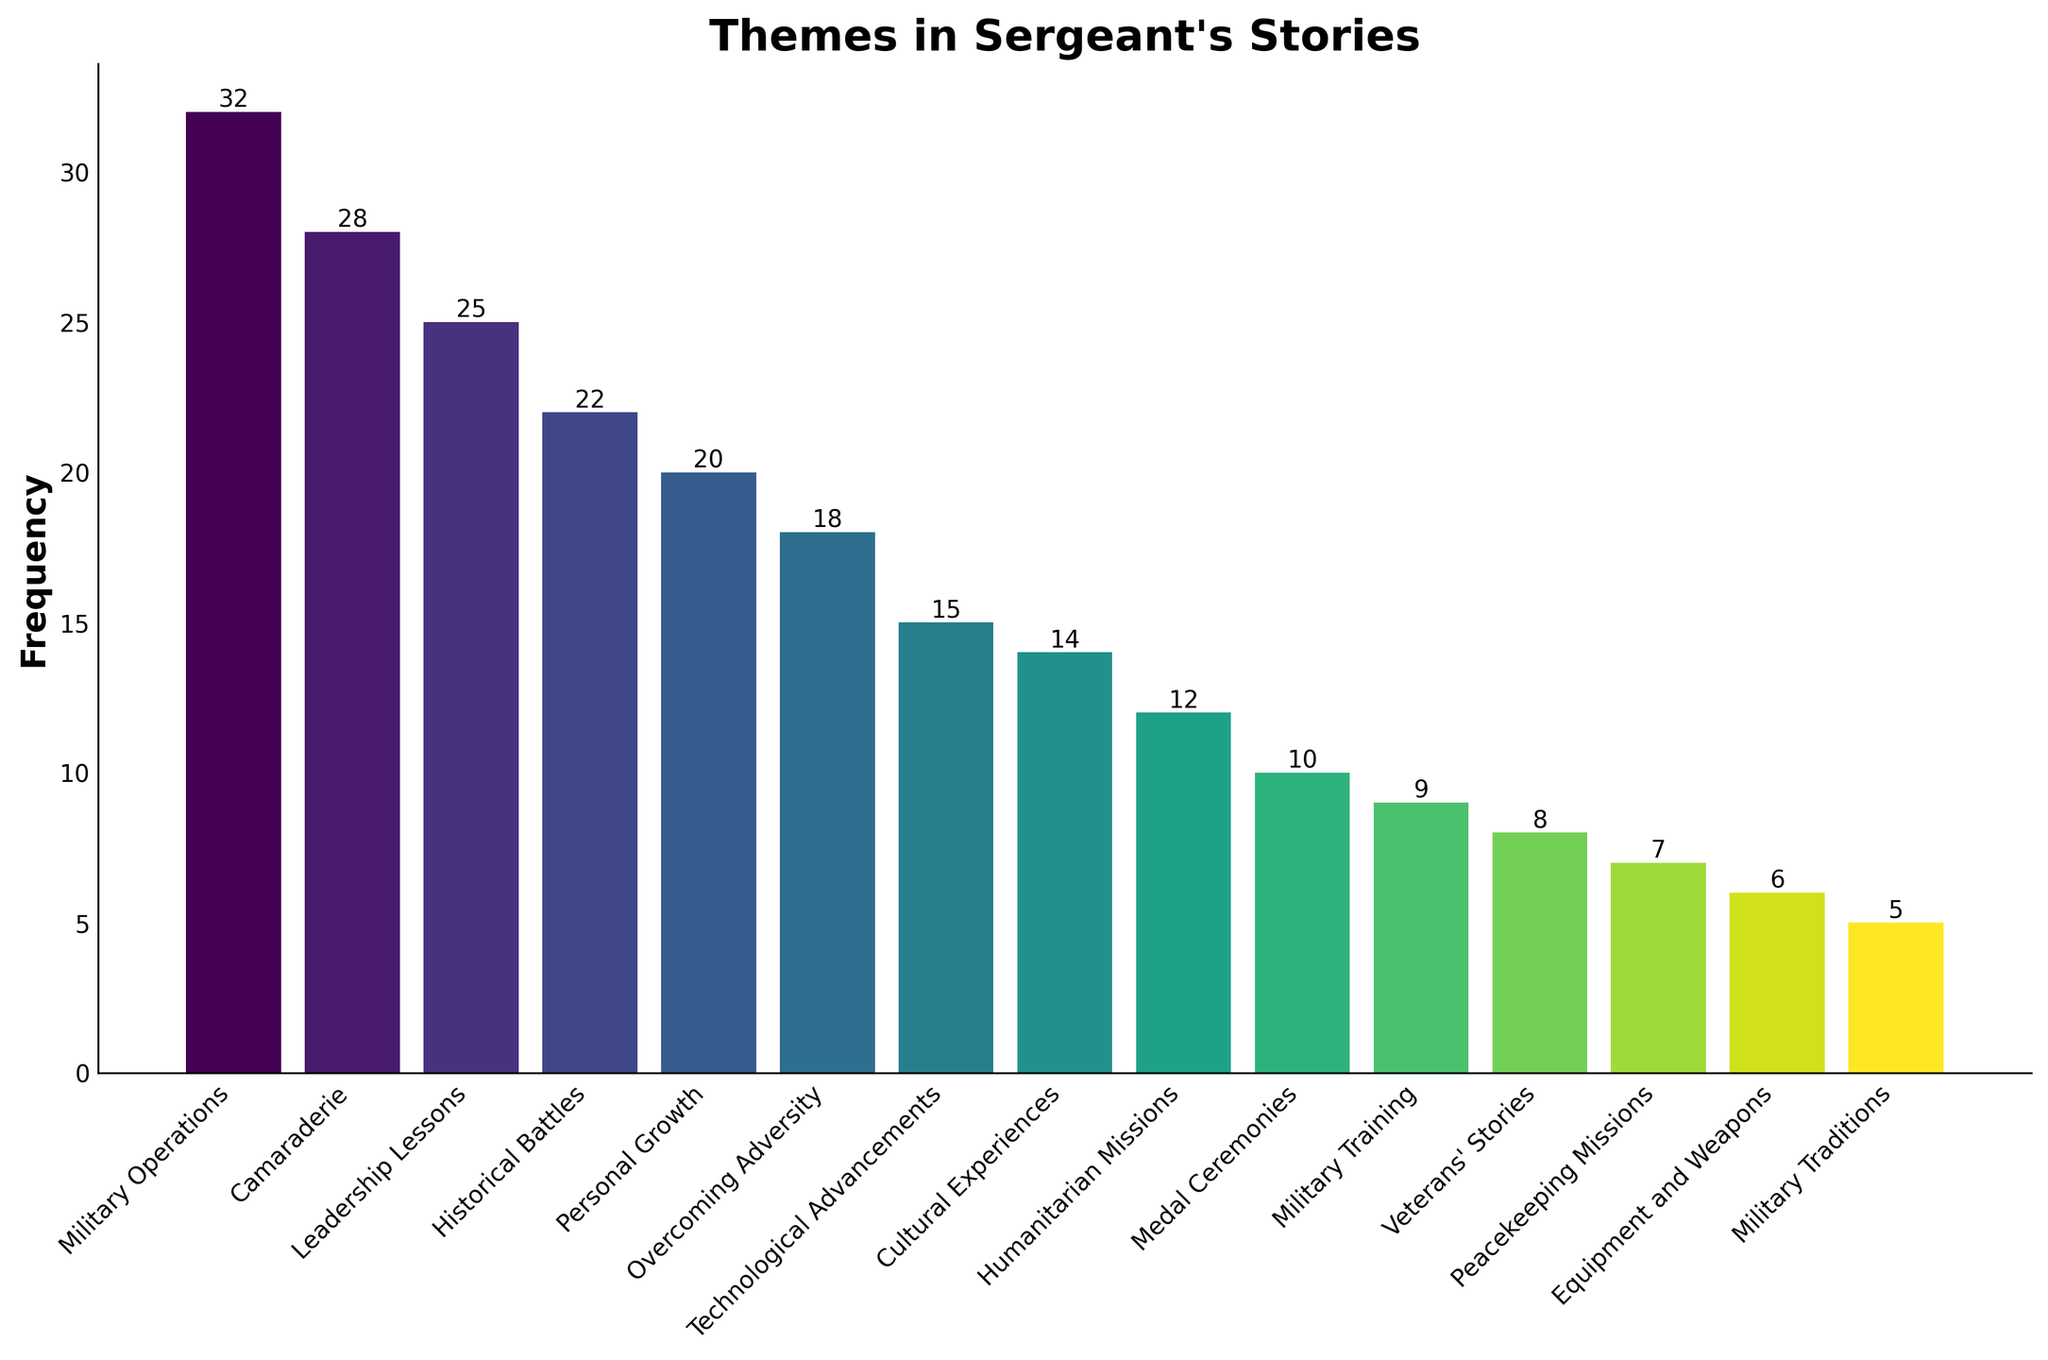What's the most frequent theme in the sergeant's stories? To find the most frequent theme, look for the bar with the highest value on the y-axis. The highest bar represents the theme "Military Operations" with a frequency of 32.
Answer: Military Operations Which theme has the least frequency in the sergeant's stories? To find the least frequent theme, identify the bar with the shortest height. The theme "Military Traditions" has the shortest bar with a frequency of 5.
Answer: Military Traditions What is the total frequency for "Leadership Lessons" and "Personal Growth"? Add the frequencies of "Leadership Lessons" (25) and "Personal Growth" (20). Thus, the total is 25 + 20 = 45.
Answer: 45 Are there more stories centered on "Technological Advancements" or "Humanitarian Missions"? Compare the heights of the bars for "Technological Advancements" and "Humanitarian Missions". "Technological Advancements" has a frequency of 15, while "Humanitarian Missions" has 12. Therefore, there are more stories about "Technological Advancements".
Answer: Technological Advancements What's the difference in frequency between the themes "Camaraderie" and "Veterans' Stories"? Subtract the frequency of "Veterans' Stories" (8) from "Camaraderie" (28). So, the difference is 28 - 8 = 20.
Answer: 20 Which themes have a frequency of more than 20? Identify all bars with a height greater than 20 on the y-axis. These themes are "Military Operations" (32), "Camaraderie" (28), "Leadership Lessons" (25), and "Historical Battles" (22).
Answer: Military Operations, Camaraderie, Leadership Lessons, Historical Battles Is the frequency of "Peacekeeping Missions" greater than or equal to the frequency of "Equipment and Weapons"? Compare the heights of the bars for "Peacekeeping Missions" and "Equipment and Weapons". "Peacekeeping Missions" has a frequency of 7, while "Equipment and Weapons" has 6. Since 7 is greater than 6, the answer is yes.
Answer: Yes What is the average frequency of the themes "Medal Ceremonies", "Military Training", and "Veterans' Stories"? Calculate the average by summing the frequencies (10 for "Medal Ceremonies", 9 for "Military Training", and 8 for "Veterans' Stories") and then dividing by the number of themes. The sum is 10 + 9 + 8 = 27, and the average is 27 / 3 = 9.
Answer: 9 